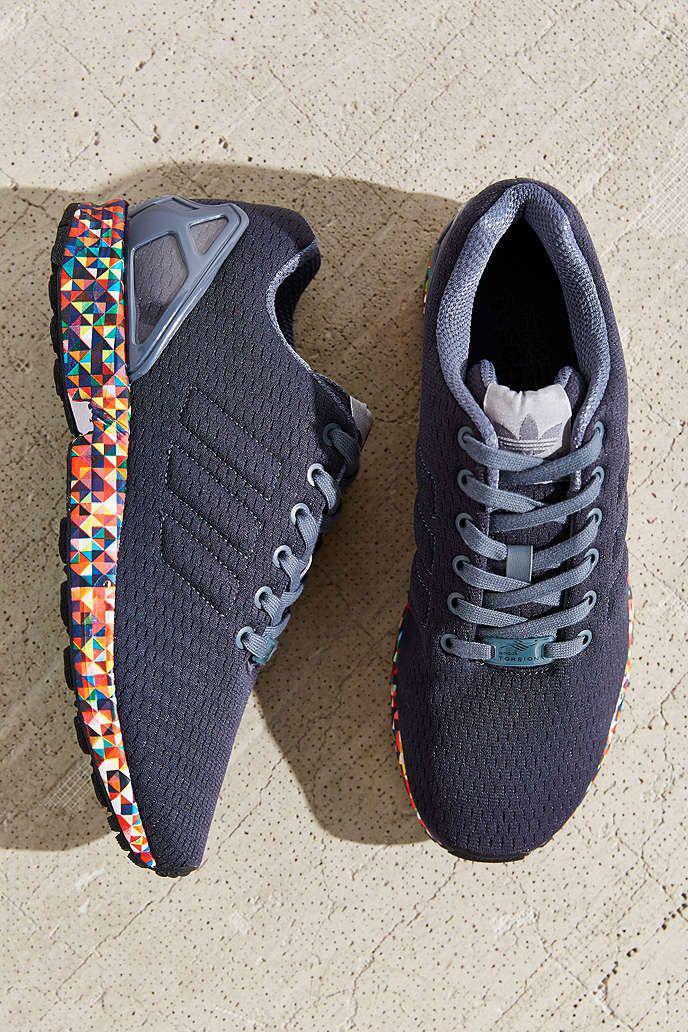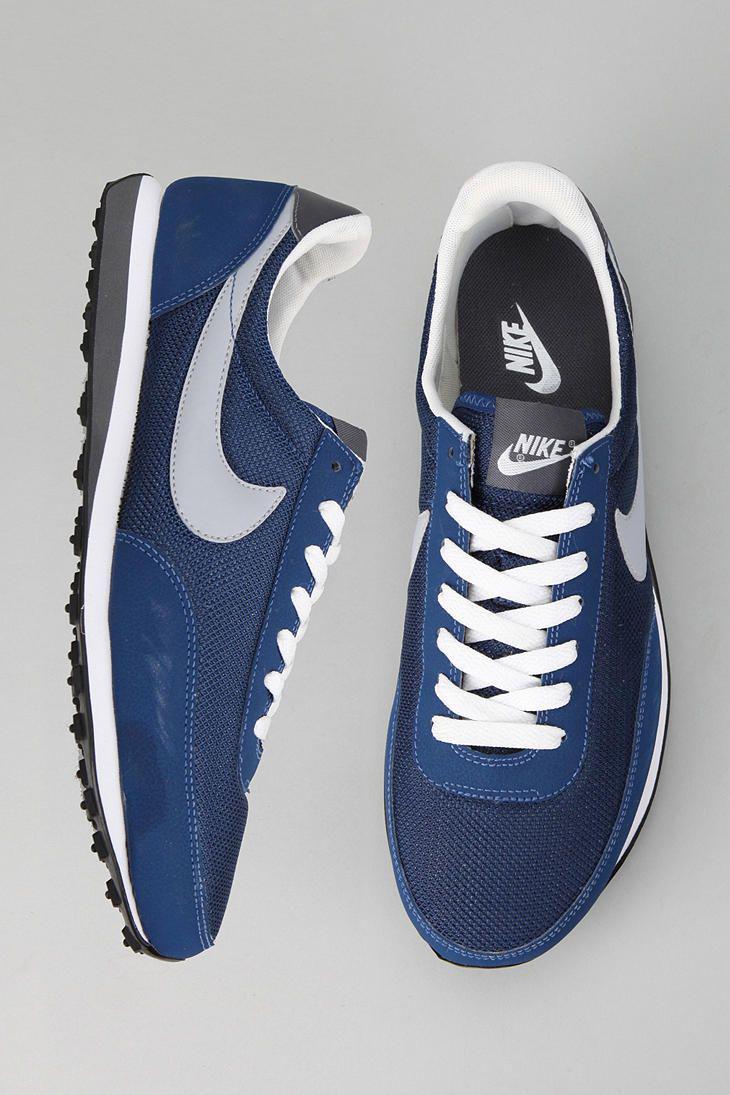The first image is the image on the left, the second image is the image on the right. Given the left and right images, does the statement "In the right image, the shoe on the right has a swoop design visible." hold true? Answer yes or no. No. 